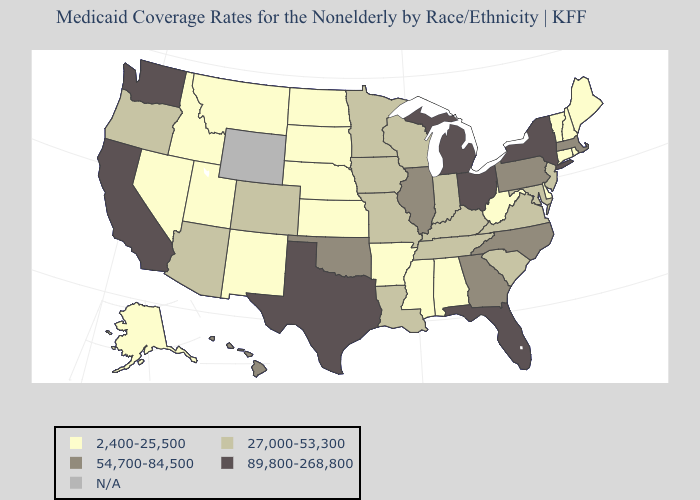What is the lowest value in the USA?
Be succinct. 2,400-25,500. Name the states that have a value in the range 2,400-25,500?
Short answer required. Alabama, Alaska, Arkansas, Connecticut, Delaware, Idaho, Kansas, Maine, Mississippi, Montana, Nebraska, Nevada, New Hampshire, New Mexico, North Dakota, Rhode Island, South Dakota, Utah, Vermont, West Virginia. Name the states that have a value in the range N/A?
Concise answer only. Wyoming. Name the states that have a value in the range 89,800-268,800?
Keep it brief. California, Florida, Michigan, New York, Ohio, Texas, Washington. Name the states that have a value in the range 2,400-25,500?
Quick response, please. Alabama, Alaska, Arkansas, Connecticut, Delaware, Idaho, Kansas, Maine, Mississippi, Montana, Nebraska, Nevada, New Hampshire, New Mexico, North Dakota, Rhode Island, South Dakota, Utah, Vermont, West Virginia. What is the highest value in the USA?
Keep it brief. 89,800-268,800. Does the map have missing data?
Give a very brief answer. Yes. Name the states that have a value in the range 2,400-25,500?
Keep it brief. Alabama, Alaska, Arkansas, Connecticut, Delaware, Idaho, Kansas, Maine, Mississippi, Montana, Nebraska, Nevada, New Hampshire, New Mexico, North Dakota, Rhode Island, South Dakota, Utah, Vermont, West Virginia. Name the states that have a value in the range 27,000-53,300?
Short answer required. Arizona, Colorado, Indiana, Iowa, Kentucky, Louisiana, Maryland, Minnesota, Missouri, New Jersey, Oregon, South Carolina, Tennessee, Virginia, Wisconsin. Name the states that have a value in the range 27,000-53,300?
Write a very short answer. Arizona, Colorado, Indiana, Iowa, Kentucky, Louisiana, Maryland, Minnesota, Missouri, New Jersey, Oregon, South Carolina, Tennessee, Virginia, Wisconsin. What is the value of Iowa?
Give a very brief answer. 27,000-53,300. What is the value of Connecticut?
Quick response, please. 2,400-25,500. 